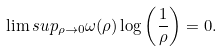Convert formula to latex. <formula><loc_0><loc_0><loc_500><loc_500>\lim s u p _ { \rho \to 0 } \omega ( \rho ) \log \left ( \frac { 1 } { \rho } \right ) = 0 .</formula> 